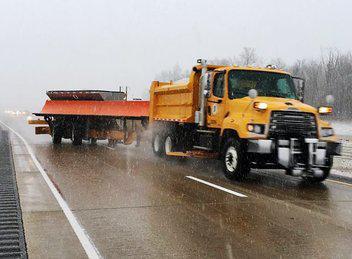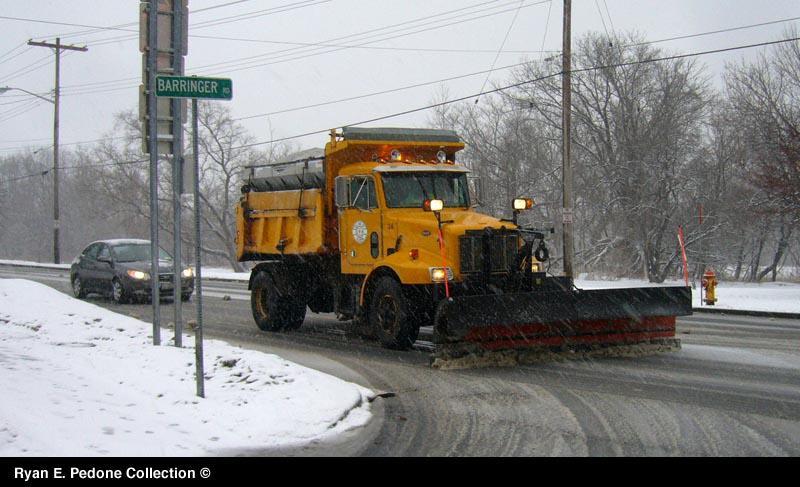The first image is the image on the left, the second image is the image on the right. Analyze the images presented: Is the assertion "The truck on the right has a plow, the truck on the left does not." valid? Answer yes or no. Yes. The first image is the image on the left, the second image is the image on the right. Considering the images on both sides, is "An image shows a yellow-cabbed truck in front of a gray building, towing a trailer with a plow on the side." valid? Answer yes or no. No. 